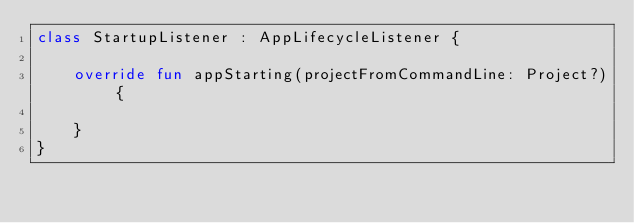<code> <loc_0><loc_0><loc_500><loc_500><_Kotlin_>class StartupListener : AppLifecycleListener {

    override fun appStarting(projectFromCommandLine: Project?) {

    }
}</code> 